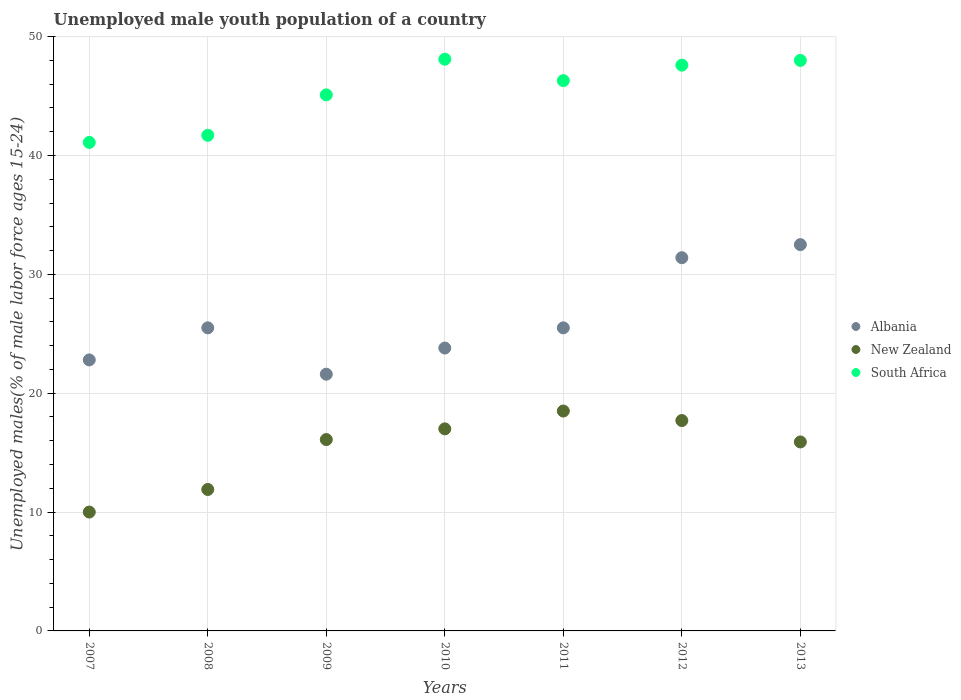What is the percentage of unemployed male youth population in South Africa in 2011?
Provide a short and direct response. 46.3. Across all years, what is the maximum percentage of unemployed male youth population in South Africa?
Your answer should be very brief. 48.1. Across all years, what is the minimum percentage of unemployed male youth population in New Zealand?
Ensure brevity in your answer.  10. In which year was the percentage of unemployed male youth population in New Zealand minimum?
Make the answer very short. 2007. What is the total percentage of unemployed male youth population in New Zealand in the graph?
Offer a very short reply. 107.1. What is the difference between the percentage of unemployed male youth population in South Africa in 2007 and that in 2012?
Offer a terse response. -6.5. What is the difference between the percentage of unemployed male youth population in Albania in 2013 and the percentage of unemployed male youth population in South Africa in 2009?
Your answer should be very brief. -12.6. What is the average percentage of unemployed male youth population in South Africa per year?
Make the answer very short. 45.41. In the year 2008, what is the difference between the percentage of unemployed male youth population in Albania and percentage of unemployed male youth population in New Zealand?
Keep it short and to the point. 13.6. What is the ratio of the percentage of unemployed male youth population in South Africa in 2007 to that in 2013?
Ensure brevity in your answer.  0.86. Is the difference between the percentage of unemployed male youth population in Albania in 2009 and 2013 greater than the difference between the percentage of unemployed male youth population in New Zealand in 2009 and 2013?
Provide a succinct answer. No. What is the difference between the highest and the second highest percentage of unemployed male youth population in New Zealand?
Your answer should be compact. 0.8. What is the difference between the highest and the lowest percentage of unemployed male youth population in New Zealand?
Your answer should be very brief. 8.5. Is the sum of the percentage of unemployed male youth population in New Zealand in 2008 and 2012 greater than the maximum percentage of unemployed male youth population in Albania across all years?
Offer a terse response. No. Is the percentage of unemployed male youth population in New Zealand strictly less than the percentage of unemployed male youth population in Albania over the years?
Your answer should be compact. Yes. How many years are there in the graph?
Your answer should be very brief. 7. Are the values on the major ticks of Y-axis written in scientific E-notation?
Offer a terse response. No. Does the graph contain grids?
Your answer should be compact. Yes. How are the legend labels stacked?
Your answer should be very brief. Vertical. What is the title of the graph?
Give a very brief answer. Unemployed male youth population of a country. What is the label or title of the Y-axis?
Your answer should be very brief. Unemployed males(% of male labor force ages 15-24). What is the Unemployed males(% of male labor force ages 15-24) in Albania in 2007?
Your answer should be very brief. 22.8. What is the Unemployed males(% of male labor force ages 15-24) in South Africa in 2007?
Ensure brevity in your answer.  41.1. What is the Unemployed males(% of male labor force ages 15-24) of Albania in 2008?
Your response must be concise. 25.5. What is the Unemployed males(% of male labor force ages 15-24) of New Zealand in 2008?
Your answer should be compact. 11.9. What is the Unemployed males(% of male labor force ages 15-24) of South Africa in 2008?
Offer a very short reply. 41.7. What is the Unemployed males(% of male labor force ages 15-24) of Albania in 2009?
Offer a very short reply. 21.6. What is the Unemployed males(% of male labor force ages 15-24) in New Zealand in 2009?
Your answer should be very brief. 16.1. What is the Unemployed males(% of male labor force ages 15-24) of South Africa in 2009?
Your answer should be very brief. 45.1. What is the Unemployed males(% of male labor force ages 15-24) of Albania in 2010?
Keep it short and to the point. 23.8. What is the Unemployed males(% of male labor force ages 15-24) in New Zealand in 2010?
Your response must be concise. 17. What is the Unemployed males(% of male labor force ages 15-24) in South Africa in 2010?
Your answer should be compact. 48.1. What is the Unemployed males(% of male labor force ages 15-24) of Albania in 2011?
Your response must be concise. 25.5. What is the Unemployed males(% of male labor force ages 15-24) in New Zealand in 2011?
Your response must be concise. 18.5. What is the Unemployed males(% of male labor force ages 15-24) of South Africa in 2011?
Keep it short and to the point. 46.3. What is the Unemployed males(% of male labor force ages 15-24) in Albania in 2012?
Offer a terse response. 31.4. What is the Unemployed males(% of male labor force ages 15-24) of New Zealand in 2012?
Give a very brief answer. 17.7. What is the Unemployed males(% of male labor force ages 15-24) of South Africa in 2012?
Your answer should be compact. 47.6. What is the Unemployed males(% of male labor force ages 15-24) in Albania in 2013?
Offer a very short reply. 32.5. What is the Unemployed males(% of male labor force ages 15-24) of New Zealand in 2013?
Your response must be concise. 15.9. Across all years, what is the maximum Unemployed males(% of male labor force ages 15-24) in Albania?
Keep it short and to the point. 32.5. Across all years, what is the maximum Unemployed males(% of male labor force ages 15-24) in New Zealand?
Provide a succinct answer. 18.5. Across all years, what is the maximum Unemployed males(% of male labor force ages 15-24) in South Africa?
Your response must be concise. 48.1. Across all years, what is the minimum Unemployed males(% of male labor force ages 15-24) of Albania?
Provide a short and direct response. 21.6. Across all years, what is the minimum Unemployed males(% of male labor force ages 15-24) of South Africa?
Keep it short and to the point. 41.1. What is the total Unemployed males(% of male labor force ages 15-24) of Albania in the graph?
Keep it short and to the point. 183.1. What is the total Unemployed males(% of male labor force ages 15-24) in New Zealand in the graph?
Ensure brevity in your answer.  107.1. What is the total Unemployed males(% of male labor force ages 15-24) in South Africa in the graph?
Give a very brief answer. 317.9. What is the difference between the Unemployed males(% of male labor force ages 15-24) in New Zealand in 2007 and that in 2008?
Your answer should be compact. -1.9. What is the difference between the Unemployed males(% of male labor force ages 15-24) in South Africa in 2007 and that in 2008?
Offer a terse response. -0.6. What is the difference between the Unemployed males(% of male labor force ages 15-24) in Albania in 2007 and that in 2010?
Ensure brevity in your answer.  -1. What is the difference between the Unemployed males(% of male labor force ages 15-24) in South Africa in 2007 and that in 2010?
Offer a terse response. -7. What is the difference between the Unemployed males(% of male labor force ages 15-24) of Albania in 2007 and that in 2011?
Offer a very short reply. -2.7. What is the difference between the Unemployed males(% of male labor force ages 15-24) of South Africa in 2007 and that in 2011?
Provide a short and direct response. -5.2. What is the difference between the Unemployed males(% of male labor force ages 15-24) of Albania in 2007 and that in 2012?
Your answer should be very brief. -8.6. What is the difference between the Unemployed males(% of male labor force ages 15-24) of Albania in 2008 and that in 2009?
Keep it short and to the point. 3.9. What is the difference between the Unemployed males(% of male labor force ages 15-24) in South Africa in 2008 and that in 2010?
Provide a short and direct response. -6.4. What is the difference between the Unemployed males(% of male labor force ages 15-24) of South Africa in 2008 and that in 2011?
Keep it short and to the point. -4.6. What is the difference between the Unemployed males(% of male labor force ages 15-24) of New Zealand in 2009 and that in 2010?
Offer a terse response. -0.9. What is the difference between the Unemployed males(% of male labor force ages 15-24) in South Africa in 2009 and that in 2010?
Ensure brevity in your answer.  -3. What is the difference between the Unemployed males(% of male labor force ages 15-24) in Albania in 2009 and that in 2011?
Provide a succinct answer. -3.9. What is the difference between the Unemployed males(% of male labor force ages 15-24) in New Zealand in 2009 and that in 2011?
Your response must be concise. -2.4. What is the difference between the Unemployed males(% of male labor force ages 15-24) of South Africa in 2009 and that in 2011?
Ensure brevity in your answer.  -1.2. What is the difference between the Unemployed males(% of male labor force ages 15-24) of Albania in 2009 and that in 2012?
Provide a succinct answer. -9.8. What is the difference between the Unemployed males(% of male labor force ages 15-24) in New Zealand in 2009 and that in 2012?
Give a very brief answer. -1.6. What is the difference between the Unemployed males(% of male labor force ages 15-24) of South Africa in 2009 and that in 2012?
Offer a very short reply. -2.5. What is the difference between the Unemployed males(% of male labor force ages 15-24) in South Africa in 2010 and that in 2011?
Provide a short and direct response. 1.8. What is the difference between the Unemployed males(% of male labor force ages 15-24) in South Africa in 2010 and that in 2012?
Provide a succinct answer. 0.5. What is the difference between the Unemployed males(% of male labor force ages 15-24) of New Zealand in 2010 and that in 2013?
Your answer should be very brief. 1.1. What is the difference between the Unemployed males(% of male labor force ages 15-24) of South Africa in 2010 and that in 2013?
Your response must be concise. 0.1. What is the difference between the Unemployed males(% of male labor force ages 15-24) in Albania in 2011 and that in 2012?
Provide a short and direct response. -5.9. What is the difference between the Unemployed males(% of male labor force ages 15-24) of New Zealand in 2011 and that in 2012?
Give a very brief answer. 0.8. What is the difference between the Unemployed males(% of male labor force ages 15-24) of Albania in 2012 and that in 2013?
Offer a very short reply. -1.1. What is the difference between the Unemployed males(% of male labor force ages 15-24) in New Zealand in 2012 and that in 2013?
Your answer should be compact. 1.8. What is the difference between the Unemployed males(% of male labor force ages 15-24) of Albania in 2007 and the Unemployed males(% of male labor force ages 15-24) of New Zealand in 2008?
Ensure brevity in your answer.  10.9. What is the difference between the Unemployed males(% of male labor force ages 15-24) in Albania in 2007 and the Unemployed males(% of male labor force ages 15-24) in South Africa in 2008?
Give a very brief answer. -18.9. What is the difference between the Unemployed males(% of male labor force ages 15-24) of New Zealand in 2007 and the Unemployed males(% of male labor force ages 15-24) of South Africa in 2008?
Offer a terse response. -31.7. What is the difference between the Unemployed males(% of male labor force ages 15-24) of Albania in 2007 and the Unemployed males(% of male labor force ages 15-24) of South Africa in 2009?
Give a very brief answer. -22.3. What is the difference between the Unemployed males(% of male labor force ages 15-24) in New Zealand in 2007 and the Unemployed males(% of male labor force ages 15-24) in South Africa in 2009?
Provide a short and direct response. -35.1. What is the difference between the Unemployed males(% of male labor force ages 15-24) of Albania in 2007 and the Unemployed males(% of male labor force ages 15-24) of South Africa in 2010?
Give a very brief answer. -25.3. What is the difference between the Unemployed males(% of male labor force ages 15-24) of New Zealand in 2007 and the Unemployed males(% of male labor force ages 15-24) of South Africa in 2010?
Make the answer very short. -38.1. What is the difference between the Unemployed males(% of male labor force ages 15-24) in Albania in 2007 and the Unemployed males(% of male labor force ages 15-24) in South Africa in 2011?
Keep it short and to the point. -23.5. What is the difference between the Unemployed males(% of male labor force ages 15-24) of New Zealand in 2007 and the Unemployed males(% of male labor force ages 15-24) of South Africa in 2011?
Keep it short and to the point. -36.3. What is the difference between the Unemployed males(% of male labor force ages 15-24) of Albania in 2007 and the Unemployed males(% of male labor force ages 15-24) of New Zealand in 2012?
Provide a succinct answer. 5.1. What is the difference between the Unemployed males(% of male labor force ages 15-24) in Albania in 2007 and the Unemployed males(% of male labor force ages 15-24) in South Africa in 2012?
Make the answer very short. -24.8. What is the difference between the Unemployed males(% of male labor force ages 15-24) of New Zealand in 2007 and the Unemployed males(% of male labor force ages 15-24) of South Africa in 2012?
Give a very brief answer. -37.6. What is the difference between the Unemployed males(% of male labor force ages 15-24) in Albania in 2007 and the Unemployed males(% of male labor force ages 15-24) in New Zealand in 2013?
Offer a terse response. 6.9. What is the difference between the Unemployed males(% of male labor force ages 15-24) in Albania in 2007 and the Unemployed males(% of male labor force ages 15-24) in South Africa in 2013?
Provide a short and direct response. -25.2. What is the difference between the Unemployed males(% of male labor force ages 15-24) of New Zealand in 2007 and the Unemployed males(% of male labor force ages 15-24) of South Africa in 2013?
Give a very brief answer. -38. What is the difference between the Unemployed males(% of male labor force ages 15-24) of Albania in 2008 and the Unemployed males(% of male labor force ages 15-24) of South Africa in 2009?
Your response must be concise. -19.6. What is the difference between the Unemployed males(% of male labor force ages 15-24) of New Zealand in 2008 and the Unemployed males(% of male labor force ages 15-24) of South Africa in 2009?
Keep it short and to the point. -33.2. What is the difference between the Unemployed males(% of male labor force ages 15-24) in Albania in 2008 and the Unemployed males(% of male labor force ages 15-24) in South Africa in 2010?
Your answer should be compact. -22.6. What is the difference between the Unemployed males(% of male labor force ages 15-24) of New Zealand in 2008 and the Unemployed males(% of male labor force ages 15-24) of South Africa in 2010?
Your response must be concise. -36.2. What is the difference between the Unemployed males(% of male labor force ages 15-24) of Albania in 2008 and the Unemployed males(% of male labor force ages 15-24) of New Zealand in 2011?
Ensure brevity in your answer.  7. What is the difference between the Unemployed males(% of male labor force ages 15-24) in Albania in 2008 and the Unemployed males(% of male labor force ages 15-24) in South Africa in 2011?
Provide a succinct answer. -20.8. What is the difference between the Unemployed males(% of male labor force ages 15-24) in New Zealand in 2008 and the Unemployed males(% of male labor force ages 15-24) in South Africa in 2011?
Your response must be concise. -34.4. What is the difference between the Unemployed males(% of male labor force ages 15-24) of Albania in 2008 and the Unemployed males(% of male labor force ages 15-24) of South Africa in 2012?
Your answer should be very brief. -22.1. What is the difference between the Unemployed males(% of male labor force ages 15-24) in New Zealand in 2008 and the Unemployed males(% of male labor force ages 15-24) in South Africa in 2012?
Offer a terse response. -35.7. What is the difference between the Unemployed males(% of male labor force ages 15-24) in Albania in 2008 and the Unemployed males(% of male labor force ages 15-24) in New Zealand in 2013?
Offer a very short reply. 9.6. What is the difference between the Unemployed males(% of male labor force ages 15-24) of Albania in 2008 and the Unemployed males(% of male labor force ages 15-24) of South Africa in 2013?
Offer a very short reply. -22.5. What is the difference between the Unemployed males(% of male labor force ages 15-24) in New Zealand in 2008 and the Unemployed males(% of male labor force ages 15-24) in South Africa in 2013?
Offer a terse response. -36.1. What is the difference between the Unemployed males(% of male labor force ages 15-24) in Albania in 2009 and the Unemployed males(% of male labor force ages 15-24) in New Zealand in 2010?
Provide a short and direct response. 4.6. What is the difference between the Unemployed males(% of male labor force ages 15-24) in Albania in 2009 and the Unemployed males(% of male labor force ages 15-24) in South Africa in 2010?
Your answer should be very brief. -26.5. What is the difference between the Unemployed males(% of male labor force ages 15-24) of New Zealand in 2009 and the Unemployed males(% of male labor force ages 15-24) of South Africa in 2010?
Make the answer very short. -32. What is the difference between the Unemployed males(% of male labor force ages 15-24) of Albania in 2009 and the Unemployed males(% of male labor force ages 15-24) of South Africa in 2011?
Provide a short and direct response. -24.7. What is the difference between the Unemployed males(% of male labor force ages 15-24) in New Zealand in 2009 and the Unemployed males(% of male labor force ages 15-24) in South Africa in 2011?
Offer a very short reply. -30.2. What is the difference between the Unemployed males(% of male labor force ages 15-24) in New Zealand in 2009 and the Unemployed males(% of male labor force ages 15-24) in South Africa in 2012?
Provide a succinct answer. -31.5. What is the difference between the Unemployed males(% of male labor force ages 15-24) in Albania in 2009 and the Unemployed males(% of male labor force ages 15-24) in New Zealand in 2013?
Ensure brevity in your answer.  5.7. What is the difference between the Unemployed males(% of male labor force ages 15-24) of Albania in 2009 and the Unemployed males(% of male labor force ages 15-24) of South Africa in 2013?
Make the answer very short. -26.4. What is the difference between the Unemployed males(% of male labor force ages 15-24) in New Zealand in 2009 and the Unemployed males(% of male labor force ages 15-24) in South Africa in 2013?
Provide a short and direct response. -31.9. What is the difference between the Unemployed males(% of male labor force ages 15-24) of Albania in 2010 and the Unemployed males(% of male labor force ages 15-24) of South Africa in 2011?
Provide a short and direct response. -22.5. What is the difference between the Unemployed males(% of male labor force ages 15-24) of New Zealand in 2010 and the Unemployed males(% of male labor force ages 15-24) of South Africa in 2011?
Provide a succinct answer. -29.3. What is the difference between the Unemployed males(% of male labor force ages 15-24) in Albania in 2010 and the Unemployed males(% of male labor force ages 15-24) in New Zealand in 2012?
Provide a succinct answer. 6.1. What is the difference between the Unemployed males(% of male labor force ages 15-24) of Albania in 2010 and the Unemployed males(% of male labor force ages 15-24) of South Africa in 2012?
Make the answer very short. -23.8. What is the difference between the Unemployed males(% of male labor force ages 15-24) of New Zealand in 2010 and the Unemployed males(% of male labor force ages 15-24) of South Africa in 2012?
Ensure brevity in your answer.  -30.6. What is the difference between the Unemployed males(% of male labor force ages 15-24) in Albania in 2010 and the Unemployed males(% of male labor force ages 15-24) in New Zealand in 2013?
Ensure brevity in your answer.  7.9. What is the difference between the Unemployed males(% of male labor force ages 15-24) in Albania in 2010 and the Unemployed males(% of male labor force ages 15-24) in South Africa in 2013?
Your answer should be very brief. -24.2. What is the difference between the Unemployed males(% of male labor force ages 15-24) of New Zealand in 2010 and the Unemployed males(% of male labor force ages 15-24) of South Africa in 2013?
Provide a succinct answer. -31. What is the difference between the Unemployed males(% of male labor force ages 15-24) in Albania in 2011 and the Unemployed males(% of male labor force ages 15-24) in South Africa in 2012?
Give a very brief answer. -22.1. What is the difference between the Unemployed males(% of male labor force ages 15-24) of New Zealand in 2011 and the Unemployed males(% of male labor force ages 15-24) of South Africa in 2012?
Offer a very short reply. -29.1. What is the difference between the Unemployed males(% of male labor force ages 15-24) in Albania in 2011 and the Unemployed males(% of male labor force ages 15-24) in New Zealand in 2013?
Your answer should be very brief. 9.6. What is the difference between the Unemployed males(% of male labor force ages 15-24) of Albania in 2011 and the Unemployed males(% of male labor force ages 15-24) of South Africa in 2013?
Your answer should be compact. -22.5. What is the difference between the Unemployed males(% of male labor force ages 15-24) of New Zealand in 2011 and the Unemployed males(% of male labor force ages 15-24) of South Africa in 2013?
Your answer should be compact. -29.5. What is the difference between the Unemployed males(% of male labor force ages 15-24) in Albania in 2012 and the Unemployed males(% of male labor force ages 15-24) in South Africa in 2013?
Offer a terse response. -16.6. What is the difference between the Unemployed males(% of male labor force ages 15-24) in New Zealand in 2012 and the Unemployed males(% of male labor force ages 15-24) in South Africa in 2013?
Offer a terse response. -30.3. What is the average Unemployed males(% of male labor force ages 15-24) of Albania per year?
Your response must be concise. 26.16. What is the average Unemployed males(% of male labor force ages 15-24) in New Zealand per year?
Offer a terse response. 15.3. What is the average Unemployed males(% of male labor force ages 15-24) in South Africa per year?
Keep it short and to the point. 45.41. In the year 2007, what is the difference between the Unemployed males(% of male labor force ages 15-24) of Albania and Unemployed males(% of male labor force ages 15-24) of New Zealand?
Offer a very short reply. 12.8. In the year 2007, what is the difference between the Unemployed males(% of male labor force ages 15-24) in Albania and Unemployed males(% of male labor force ages 15-24) in South Africa?
Offer a very short reply. -18.3. In the year 2007, what is the difference between the Unemployed males(% of male labor force ages 15-24) of New Zealand and Unemployed males(% of male labor force ages 15-24) of South Africa?
Your answer should be compact. -31.1. In the year 2008, what is the difference between the Unemployed males(% of male labor force ages 15-24) in Albania and Unemployed males(% of male labor force ages 15-24) in New Zealand?
Your answer should be compact. 13.6. In the year 2008, what is the difference between the Unemployed males(% of male labor force ages 15-24) in Albania and Unemployed males(% of male labor force ages 15-24) in South Africa?
Make the answer very short. -16.2. In the year 2008, what is the difference between the Unemployed males(% of male labor force ages 15-24) of New Zealand and Unemployed males(% of male labor force ages 15-24) of South Africa?
Ensure brevity in your answer.  -29.8. In the year 2009, what is the difference between the Unemployed males(% of male labor force ages 15-24) of Albania and Unemployed males(% of male labor force ages 15-24) of South Africa?
Keep it short and to the point. -23.5. In the year 2010, what is the difference between the Unemployed males(% of male labor force ages 15-24) of Albania and Unemployed males(% of male labor force ages 15-24) of New Zealand?
Your answer should be very brief. 6.8. In the year 2010, what is the difference between the Unemployed males(% of male labor force ages 15-24) of Albania and Unemployed males(% of male labor force ages 15-24) of South Africa?
Your answer should be compact. -24.3. In the year 2010, what is the difference between the Unemployed males(% of male labor force ages 15-24) in New Zealand and Unemployed males(% of male labor force ages 15-24) in South Africa?
Give a very brief answer. -31.1. In the year 2011, what is the difference between the Unemployed males(% of male labor force ages 15-24) of Albania and Unemployed males(% of male labor force ages 15-24) of New Zealand?
Your response must be concise. 7. In the year 2011, what is the difference between the Unemployed males(% of male labor force ages 15-24) of Albania and Unemployed males(% of male labor force ages 15-24) of South Africa?
Your response must be concise. -20.8. In the year 2011, what is the difference between the Unemployed males(% of male labor force ages 15-24) of New Zealand and Unemployed males(% of male labor force ages 15-24) of South Africa?
Give a very brief answer. -27.8. In the year 2012, what is the difference between the Unemployed males(% of male labor force ages 15-24) of Albania and Unemployed males(% of male labor force ages 15-24) of New Zealand?
Provide a succinct answer. 13.7. In the year 2012, what is the difference between the Unemployed males(% of male labor force ages 15-24) in Albania and Unemployed males(% of male labor force ages 15-24) in South Africa?
Ensure brevity in your answer.  -16.2. In the year 2012, what is the difference between the Unemployed males(% of male labor force ages 15-24) in New Zealand and Unemployed males(% of male labor force ages 15-24) in South Africa?
Your answer should be compact. -29.9. In the year 2013, what is the difference between the Unemployed males(% of male labor force ages 15-24) in Albania and Unemployed males(% of male labor force ages 15-24) in South Africa?
Keep it short and to the point. -15.5. In the year 2013, what is the difference between the Unemployed males(% of male labor force ages 15-24) of New Zealand and Unemployed males(% of male labor force ages 15-24) of South Africa?
Make the answer very short. -32.1. What is the ratio of the Unemployed males(% of male labor force ages 15-24) of Albania in 2007 to that in 2008?
Your response must be concise. 0.89. What is the ratio of the Unemployed males(% of male labor force ages 15-24) of New Zealand in 2007 to that in 2008?
Offer a terse response. 0.84. What is the ratio of the Unemployed males(% of male labor force ages 15-24) of South Africa in 2007 to that in 2008?
Give a very brief answer. 0.99. What is the ratio of the Unemployed males(% of male labor force ages 15-24) in Albania in 2007 to that in 2009?
Offer a very short reply. 1.06. What is the ratio of the Unemployed males(% of male labor force ages 15-24) of New Zealand in 2007 to that in 2009?
Give a very brief answer. 0.62. What is the ratio of the Unemployed males(% of male labor force ages 15-24) of South Africa in 2007 to that in 2009?
Provide a succinct answer. 0.91. What is the ratio of the Unemployed males(% of male labor force ages 15-24) in Albania in 2007 to that in 2010?
Offer a very short reply. 0.96. What is the ratio of the Unemployed males(% of male labor force ages 15-24) in New Zealand in 2007 to that in 2010?
Give a very brief answer. 0.59. What is the ratio of the Unemployed males(% of male labor force ages 15-24) of South Africa in 2007 to that in 2010?
Keep it short and to the point. 0.85. What is the ratio of the Unemployed males(% of male labor force ages 15-24) in Albania in 2007 to that in 2011?
Provide a succinct answer. 0.89. What is the ratio of the Unemployed males(% of male labor force ages 15-24) in New Zealand in 2007 to that in 2011?
Make the answer very short. 0.54. What is the ratio of the Unemployed males(% of male labor force ages 15-24) of South Africa in 2007 to that in 2011?
Give a very brief answer. 0.89. What is the ratio of the Unemployed males(% of male labor force ages 15-24) in Albania in 2007 to that in 2012?
Offer a terse response. 0.73. What is the ratio of the Unemployed males(% of male labor force ages 15-24) of New Zealand in 2007 to that in 2012?
Provide a short and direct response. 0.56. What is the ratio of the Unemployed males(% of male labor force ages 15-24) of South Africa in 2007 to that in 2012?
Keep it short and to the point. 0.86. What is the ratio of the Unemployed males(% of male labor force ages 15-24) of Albania in 2007 to that in 2013?
Keep it short and to the point. 0.7. What is the ratio of the Unemployed males(% of male labor force ages 15-24) of New Zealand in 2007 to that in 2013?
Ensure brevity in your answer.  0.63. What is the ratio of the Unemployed males(% of male labor force ages 15-24) of South Africa in 2007 to that in 2013?
Offer a terse response. 0.86. What is the ratio of the Unemployed males(% of male labor force ages 15-24) in Albania in 2008 to that in 2009?
Make the answer very short. 1.18. What is the ratio of the Unemployed males(% of male labor force ages 15-24) of New Zealand in 2008 to that in 2009?
Offer a very short reply. 0.74. What is the ratio of the Unemployed males(% of male labor force ages 15-24) in South Africa in 2008 to that in 2009?
Ensure brevity in your answer.  0.92. What is the ratio of the Unemployed males(% of male labor force ages 15-24) in Albania in 2008 to that in 2010?
Provide a succinct answer. 1.07. What is the ratio of the Unemployed males(% of male labor force ages 15-24) of South Africa in 2008 to that in 2010?
Provide a short and direct response. 0.87. What is the ratio of the Unemployed males(% of male labor force ages 15-24) of New Zealand in 2008 to that in 2011?
Your answer should be compact. 0.64. What is the ratio of the Unemployed males(% of male labor force ages 15-24) of South Africa in 2008 to that in 2011?
Your answer should be very brief. 0.9. What is the ratio of the Unemployed males(% of male labor force ages 15-24) of Albania in 2008 to that in 2012?
Provide a short and direct response. 0.81. What is the ratio of the Unemployed males(% of male labor force ages 15-24) in New Zealand in 2008 to that in 2012?
Provide a short and direct response. 0.67. What is the ratio of the Unemployed males(% of male labor force ages 15-24) of South Africa in 2008 to that in 2012?
Provide a succinct answer. 0.88. What is the ratio of the Unemployed males(% of male labor force ages 15-24) of Albania in 2008 to that in 2013?
Offer a very short reply. 0.78. What is the ratio of the Unemployed males(% of male labor force ages 15-24) of New Zealand in 2008 to that in 2013?
Provide a succinct answer. 0.75. What is the ratio of the Unemployed males(% of male labor force ages 15-24) in South Africa in 2008 to that in 2013?
Offer a very short reply. 0.87. What is the ratio of the Unemployed males(% of male labor force ages 15-24) of Albania in 2009 to that in 2010?
Offer a very short reply. 0.91. What is the ratio of the Unemployed males(% of male labor force ages 15-24) of New Zealand in 2009 to that in 2010?
Provide a succinct answer. 0.95. What is the ratio of the Unemployed males(% of male labor force ages 15-24) in South Africa in 2009 to that in 2010?
Your answer should be very brief. 0.94. What is the ratio of the Unemployed males(% of male labor force ages 15-24) of Albania in 2009 to that in 2011?
Keep it short and to the point. 0.85. What is the ratio of the Unemployed males(% of male labor force ages 15-24) in New Zealand in 2009 to that in 2011?
Your answer should be compact. 0.87. What is the ratio of the Unemployed males(% of male labor force ages 15-24) in South Africa in 2009 to that in 2011?
Provide a short and direct response. 0.97. What is the ratio of the Unemployed males(% of male labor force ages 15-24) in Albania in 2009 to that in 2012?
Offer a terse response. 0.69. What is the ratio of the Unemployed males(% of male labor force ages 15-24) of New Zealand in 2009 to that in 2012?
Provide a short and direct response. 0.91. What is the ratio of the Unemployed males(% of male labor force ages 15-24) in South Africa in 2009 to that in 2012?
Offer a terse response. 0.95. What is the ratio of the Unemployed males(% of male labor force ages 15-24) of Albania in 2009 to that in 2013?
Keep it short and to the point. 0.66. What is the ratio of the Unemployed males(% of male labor force ages 15-24) in New Zealand in 2009 to that in 2013?
Ensure brevity in your answer.  1.01. What is the ratio of the Unemployed males(% of male labor force ages 15-24) in South Africa in 2009 to that in 2013?
Ensure brevity in your answer.  0.94. What is the ratio of the Unemployed males(% of male labor force ages 15-24) in Albania in 2010 to that in 2011?
Give a very brief answer. 0.93. What is the ratio of the Unemployed males(% of male labor force ages 15-24) in New Zealand in 2010 to that in 2011?
Make the answer very short. 0.92. What is the ratio of the Unemployed males(% of male labor force ages 15-24) of South Africa in 2010 to that in 2011?
Keep it short and to the point. 1.04. What is the ratio of the Unemployed males(% of male labor force ages 15-24) in Albania in 2010 to that in 2012?
Provide a succinct answer. 0.76. What is the ratio of the Unemployed males(% of male labor force ages 15-24) in New Zealand in 2010 to that in 2012?
Keep it short and to the point. 0.96. What is the ratio of the Unemployed males(% of male labor force ages 15-24) in South Africa in 2010 to that in 2012?
Keep it short and to the point. 1.01. What is the ratio of the Unemployed males(% of male labor force ages 15-24) in Albania in 2010 to that in 2013?
Offer a terse response. 0.73. What is the ratio of the Unemployed males(% of male labor force ages 15-24) in New Zealand in 2010 to that in 2013?
Your answer should be compact. 1.07. What is the ratio of the Unemployed males(% of male labor force ages 15-24) in Albania in 2011 to that in 2012?
Offer a terse response. 0.81. What is the ratio of the Unemployed males(% of male labor force ages 15-24) in New Zealand in 2011 to that in 2012?
Ensure brevity in your answer.  1.05. What is the ratio of the Unemployed males(% of male labor force ages 15-24) in South Africa in 2011 to that in 2012?
Make the answer very short. 0.97. What is the ratio of the Unemployed males(% of male labor force ages 15-24) in Albania in 2011 to that in 2013?
Your response must be concise. 0.78. What is the ratio of the Unemployed males(% of male labor force ages 15-24) of New Zealand in 2011 to that in 2013?
Provide a short and direct response. 1.16. What is the ratio of the Unemployed males(% of male labor force ages 15-24) of South Africa in 2011 to that in 2013?
Give a very brief answer. 0.96. What is the ratio of the Unemployed males(% of male labor force ages 15-24) of Albania in 2012 to that in 2013?
Provide a short and direct response. 0.97. What is the ratio of the Unemployed males(% of male labor force ages 15-24) in New Zealand in 2012 to that in 2013?
Provide a succinct answer. 1.11. What is the ratio of the Unemployed males(% of male labor force ages 15-24) of South Africa in 2012 to that in 2013?
Provide a short and direct response. 0.99. What is the difference between the highest and the second highest Unemployed males(% of male labor force ages 15-24) in New Zealand?
Provide a short and direct response. 0.8. What is the difference between the highest and the second highest Unemployed males(% of male labor force ages 15-24) of South Africa?
Your answer should be compact. 0.1. What is the difference between the highest and the lowest Unemployed males(% of male labor force ages 15-24) in Albania?
Your answer should be very brief. 10.9. What is the difference between the highest and the lowest Unemployed males(% of male labor force ages 15-24) of South Africa?
Your answer should be very brief. 7. 